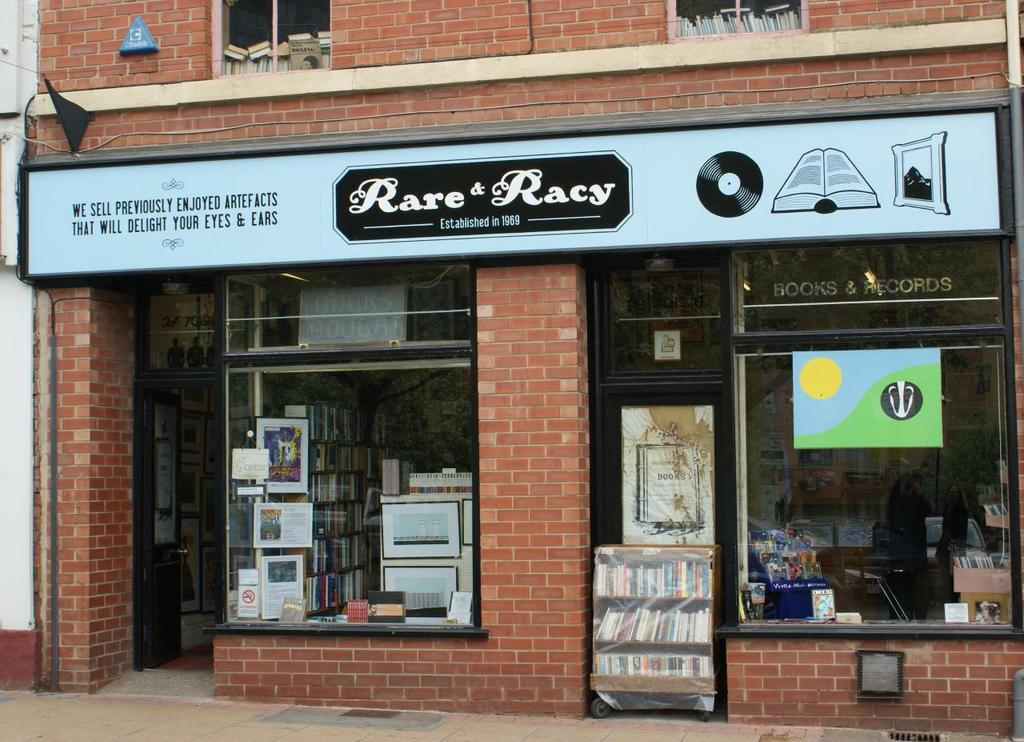<image>
Describe the image concisely. Store front that has a sign which says Rare & Racy. 